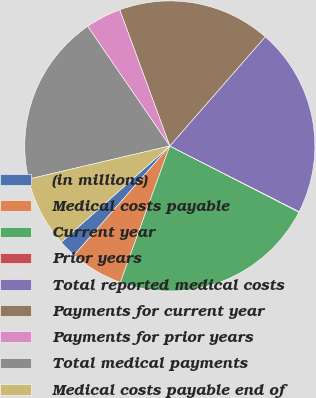Convert chart to OTSL. <chart><loc_0><loc_0><loc_500><loc_500><pie_chart><fcel>(in millions)<fcel>Medical costs payable<fcel>Current year<fcel>Prior years<fcel>Total reported medical costs<fcel>Payments for current year<fcel>Payments for prior years<fcel>Total medical payments<fcel>Medical costs payable end of<nl><fcel>2.01%<fcel>5.92%<fcel>23.0%<fcel>0.06%<fcel>21.05%<fcel>17.03%<fcel>3.97%<fcel>19.09%<fcel>7.87%<nl></chart> 